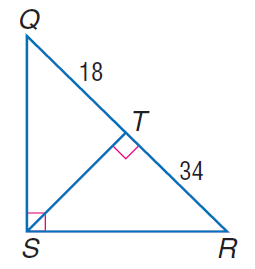Question: Find the measure of the altitude drawn to the hypotenuse.
Choices:
A. 18
B. \sqrt { 612 }
C. 34
D. 612
Answer with the letter. Answer: B 